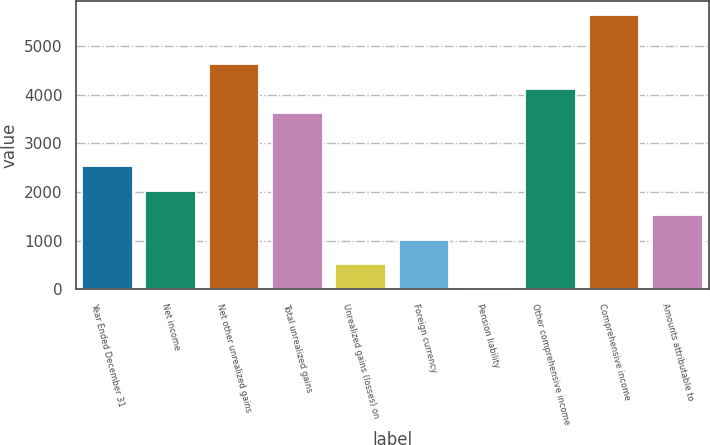<chart> <loc_0><loc_0><loc_500><loc_500><bar_chart><fcel>Year Ended December 31<fcel>Net income<fcel>Net other unrealized gains<fcel>Total unrealized gains<fcel>Unrealized gains (losses) on<fcel>Foreign currency<fcel>Pension liability<fcel>Other comprehensive income<fcel>Comprehensive income<fcel>Amounts attributable to<nl><fcel>2530.5<fcel>2025.6<fcel>4625.8<fcel>3616<fcel>510.9<fcel>1015.8<fcel>6<fcel>4120.9<fcel>5635.6<fcel>1520.7<nl></chart> 